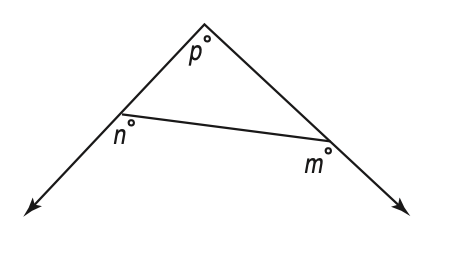Answer the mathemtical geometry problem and directly provide the correct option letter.
Question: In the figure at the right, what is the value of p in terms of m and n?
Choices: A: 360 - (m - n) B: m + n + 180 C: m + n - 180 D: m - n + 360 C 